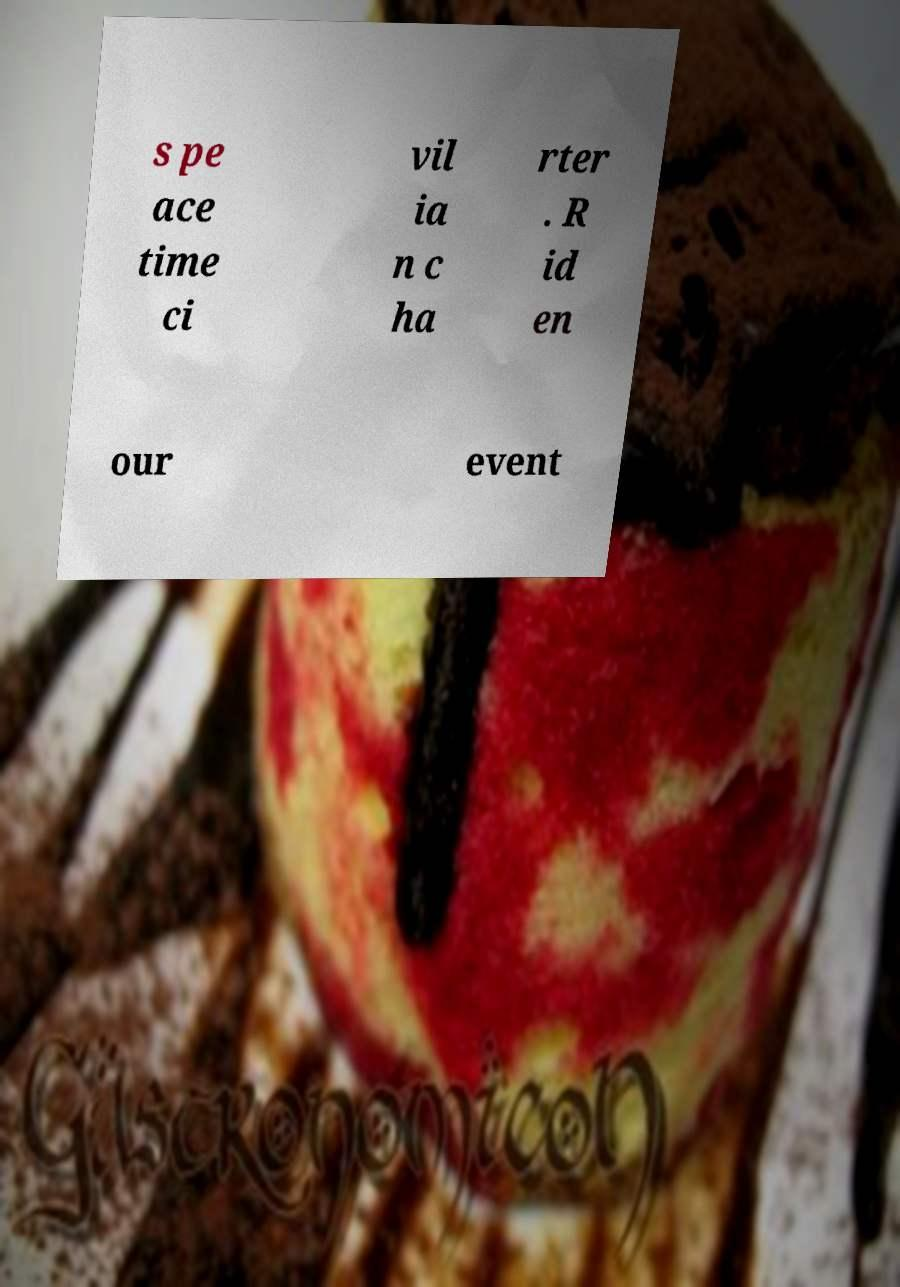Can you accurately transcribe the text from the provided image for me? s pe ace time ci vil ia n c ha rter . R id en our event 